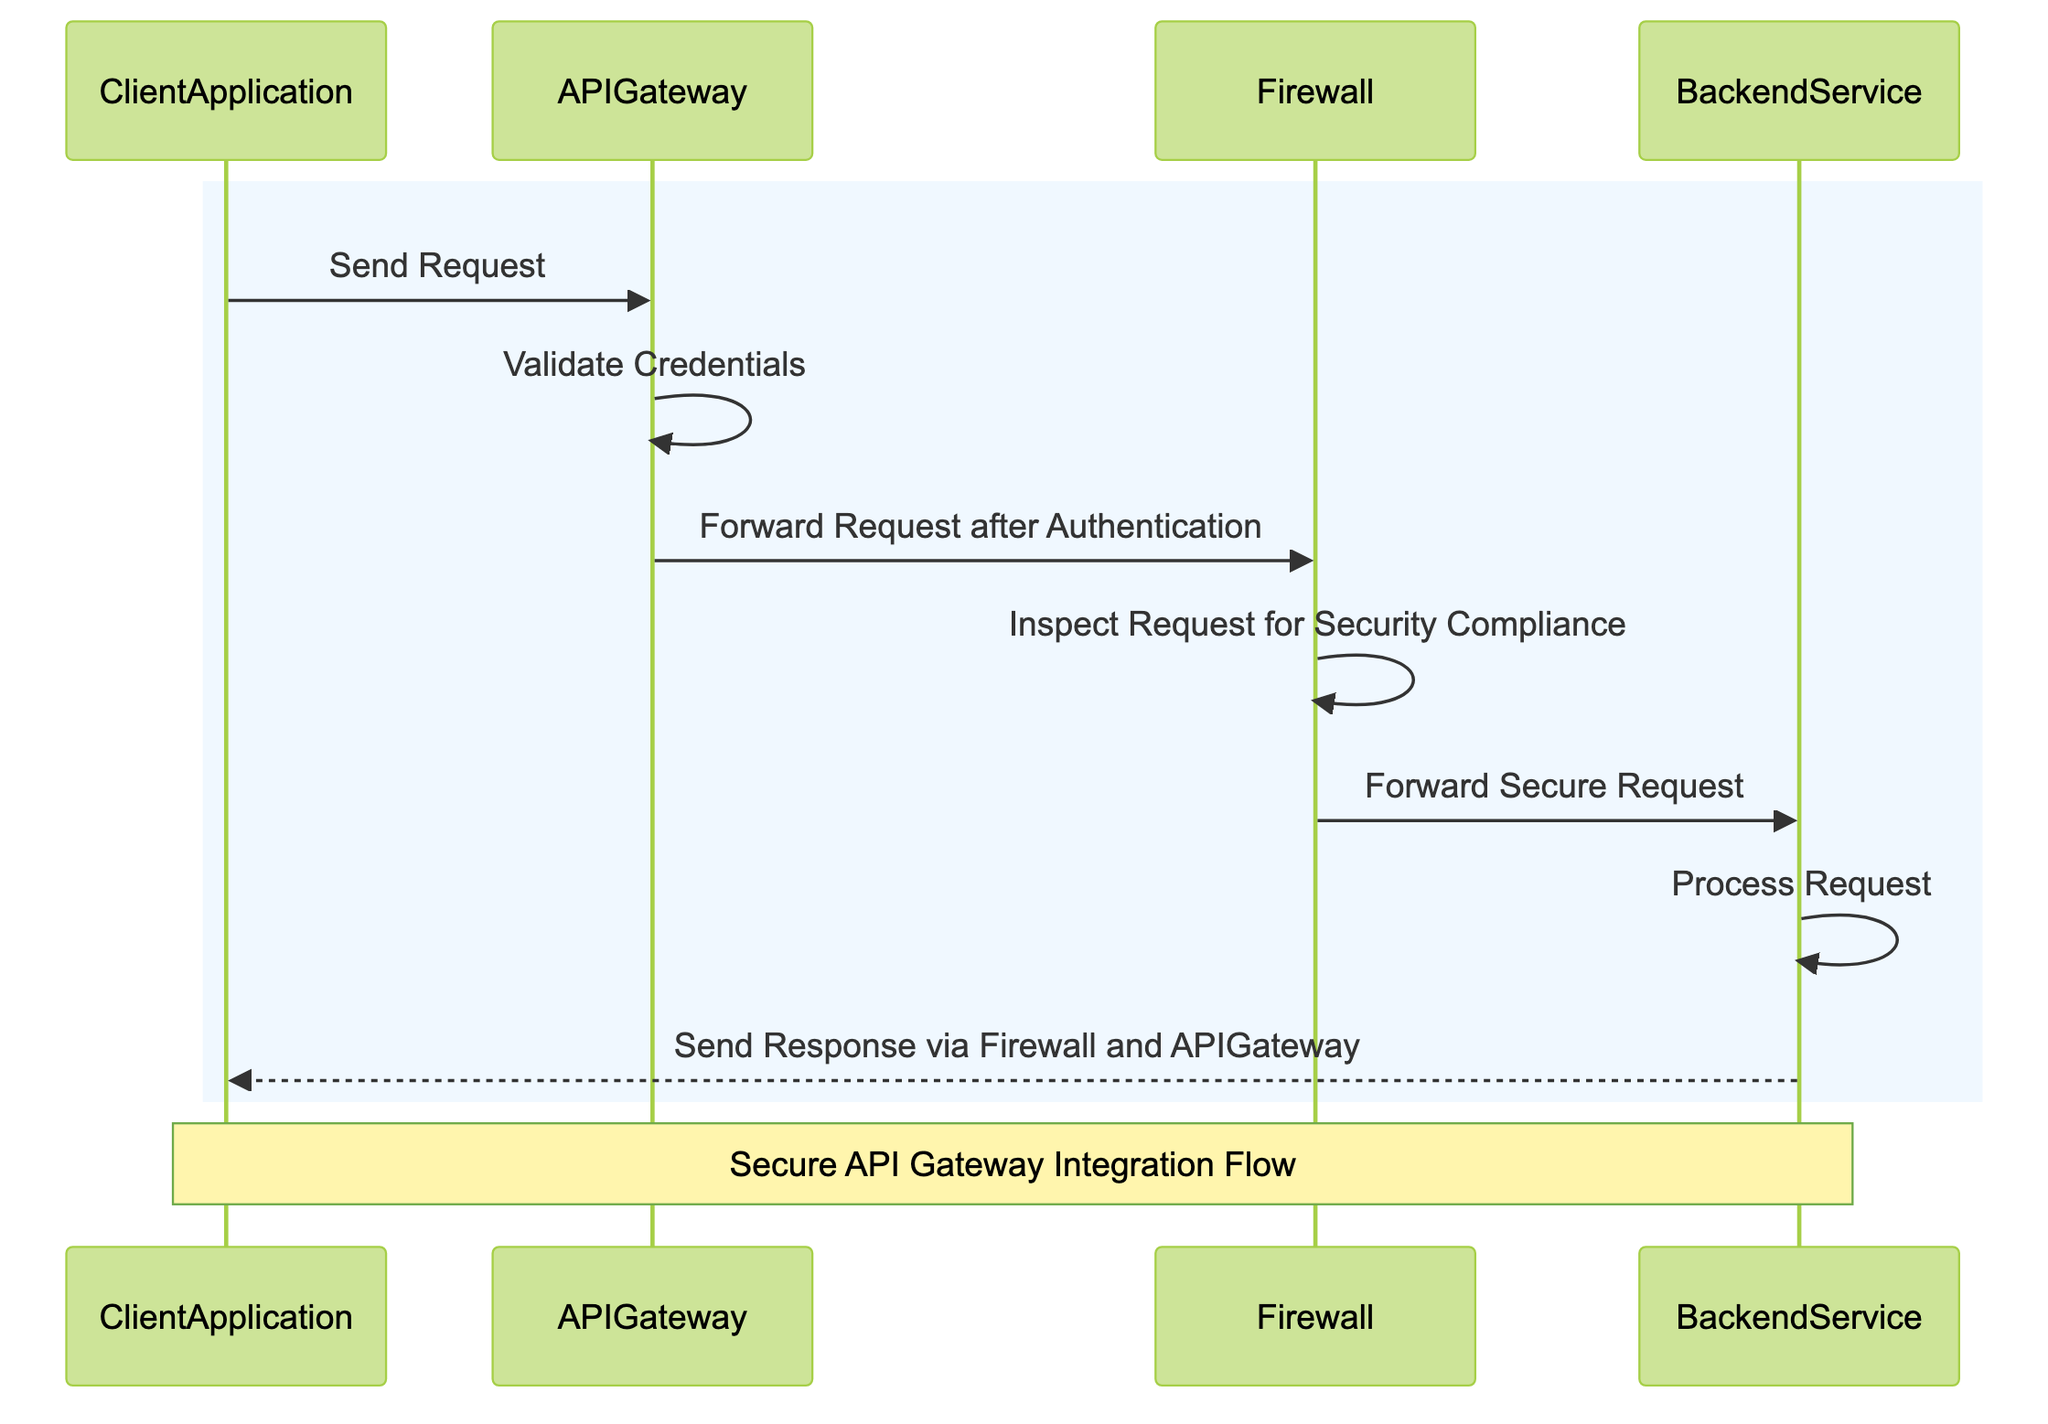What is the first action performed in the sequence? The first action is "Send Request" from the ClientApplication to the APIGateway. This can be observed as the initial arrow in the sequence diagram.
Answer: Send Request How many total actors are involved in this diagram? There are four actors listed in the diagram: ClientApplication, APIGateway, Firewall, and BackendService. Simply count the entities represented.
Answer: 4 What does the APIGateway do after receiving the request? After receiving the request, the APIGateway performs the action "Validate Credentials", which immediately follows the request in the diagram's flow.
Answer: Validate Credentials Which service inspects the request for security compliance? The Firewall service is responsible for inspecting the request for security compliance, as indicated by the message directed to itself.
Answer: Firewall What is the last service to process the request before sending a response? The last service to process the request is the BackendService, which processes the request before responding to the ClientApplication.
Answer: BackendService What is sent back to the ClientApplication? The final response sent back to the ClientApplication is a "Send Response" message, which is executed by the BackendService via the Firewall and APIGateway.
Answer: Send Response How many steps are there from request initiation to response? There are seven distinct steps from the initiation of the request to the response being sent back, as detailed in the sequence of messages in the diagram.
Answer: 7 What service forwards the secure request to the BackendService? The Firewall service is responsible for forwarding the secure request to the BackendService as indicated in the diagram flow.
Answer: Firewall Which two services are involved in the response process to the ClientApplication? The two services involved in the response process are the BackendService and the APIGateway, as they collectively send the response back to the ClientApplication.
Answer: BackendService and APIGateway 